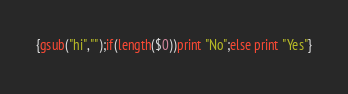<code> <loc_0><loc_0><loc_500><loc_500><_Awk_>{gsub("hi","");if(length($0))print "No";else print "Yes"}</code> 